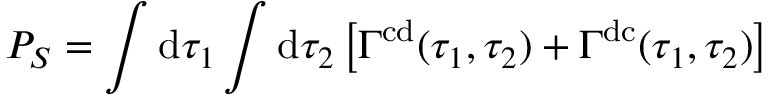Convert formula to latex. <formula><loc_0><loc_0><loc_500><loc_500>P _ { S } = \int d \tau _ { 1 } \int d \tau _ { 2 } \left [ \Gamma ^ { c d } ( \tau _ { 1 } , \tau _ { 2 } ) + \Gamma ^ { d c } ( \tau _ { 1 } , \tau _ { 2 } ) \right ]</formula> 